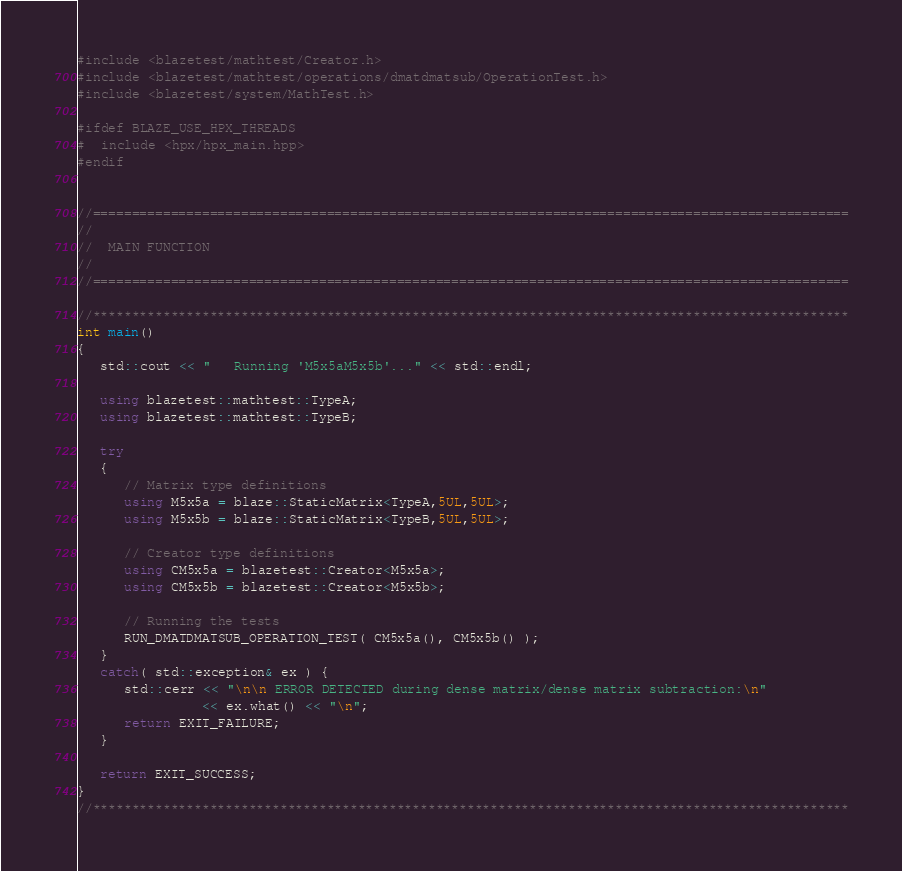<code> <loc_0><loc_0><loc_500><loc_500><_C++_>#include <blazetest/mathtest/Creator.h>
#include <blazetest/mathtest/operations/dmatdmatsub/OperationTest.h>
#include <blazetest/system/MathTest.h>

#ifdef BLAZE_USE_HPX_THREADS
#  include <hpx/hpx_main.hpp>
#endif


//=================================================================================================
//
//  MAIN FUNCTION
//
//=================================================================================================

//*************************************************************************************************
int main()
{
   std::cout << "   Running 'M5x5aM5x5b'..." << std::endl;

   using blazetest::mathtest::TypeA;
   using blazetest::mathtest::TypeB;

   try
   {
      // Matrix type definitions
      using M5x5a = blaze::StaticMatrix<TypeA,5UL,5UL>;
      using M5x5b = blaze::StaticMatrix<TypeB,5UL,5UL>;

      // Creator type definitions
      using CM5x5a = blazetest::Creator<M5x5a>;
      using CM5x5b = blazetest::Creator<M5x5b>;

      // Running the tests
      RUN_DMATDMATSUB_OPERATION_TEST( CM5x5a(), CM5x5b() );
   }
   catch( std::exception& ex ) {
      std::cerr << "\n\n ERROR DETECTED during dense matrix/dense matrix subtraction:\n"
                << ex.what() << "\n";
      return EXIT_FAILURE;
   }

   return EXIT_SUCCESS;
}
//*************************************************************************************************
</code> 